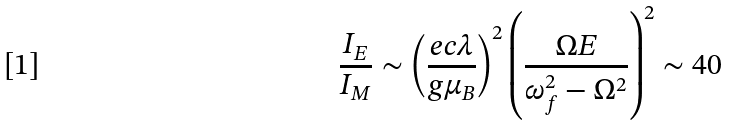<formula> <loc_0><loc_0><loc_500><loc_500>\frac { I _ { E } } { I _ { M } } \sim \left ( \frac { e c \lambda } { g \mu _ { B } } \right ) ^ { 2 } \left ( \frac { \Omega E } { \omega _ { f } ^ { 2 } - \Omega ^ { 2 } } \right ) ^ { 2 } \sim 4 0</formula> 